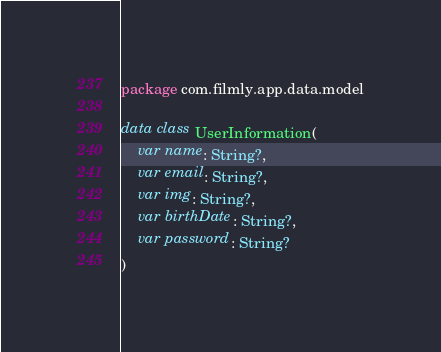<code> <loc_0><loc_0><loc_500><loc_500><_Kotlin_>package com.filmly.app.data.model

data class UserInformation(
    var name: String?,
    var email: String?,
    var img: String?,
    var birthDate: String?,
    var password: String?
)</code> 